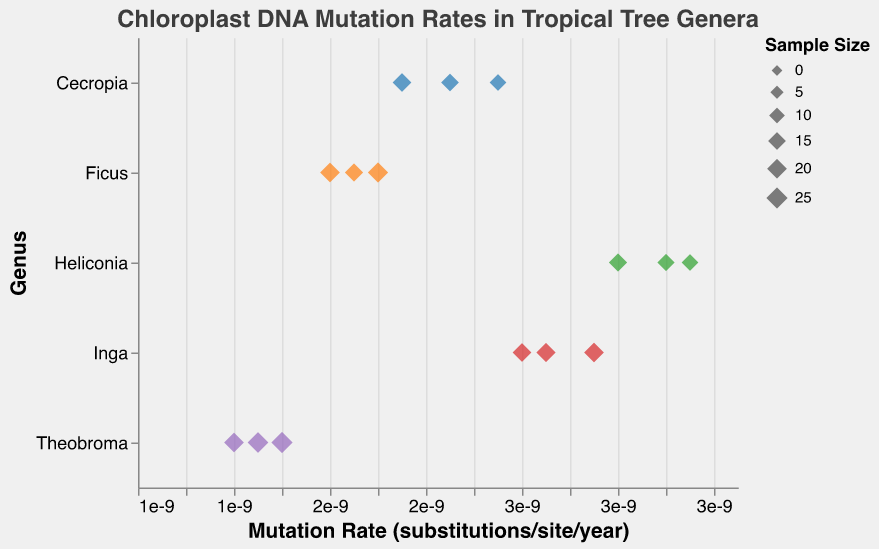What's the subject of the plot? The title of the plot is "Chloroplast DNA Mutation Rates in Tropical Tree Genera." This title tells us that the plot is about the mutation rates of chloroplast DNA among different genera of tropical trees.
Answer: Chloroplast DNA Mutation Rates in Tropical Tree Genera Which genus has the highest mutation rate? By looking at the x-axis and identifying the point farthest to the right, we see that Heliconia has the highest mutation rate, approximately 3.3e-9 substitutions per site per year.
Answer: Heliconia What are the approximate mutation rates for Cecropia? The points for Cecropia are at 2.1e-9, 2.3e-9, and 2.5e-9 mutations per site per year, as visible on the x-axis under the Cecropia genus.
Answer: 2.1e-9, 2.3e-9, 2.5e-9 How does the sample size affect the visual representation of the data points? The size of each point is determined by the sample size. Larger sample sizes appear as larger points. For example, in the genus Inga, points with sample sizes 19, 21, and 18 are different sizes accordingly.
Answer: Larger sample sizes result in larger points Which genus has the smallest range of mutation rates? By observing the spread of the data points on the x-axis for each genus, Theobroma has the smallest range of mutation rates, evidenced by the points being closely clustered around 1.45e-9 to 1.6e-9.
Answer: Theobroma What is the average mutation rate for Inga? The mutation rates for Inga are 2.6e-9, 2.7e-9, and 2.9e-9. Adding them up gives 8.2e-9 and dividing by 3 results in an average mutation rate of approximately 2.73e-9.
Answer: 2.73e-9 Which genera have overlapping mutation rates? By comparing the ranges of mutation rates visually on the x-axis, the genera Cecropia and Ficus have overlapping mutation rates.
Answer: Cecropia and Ficus 